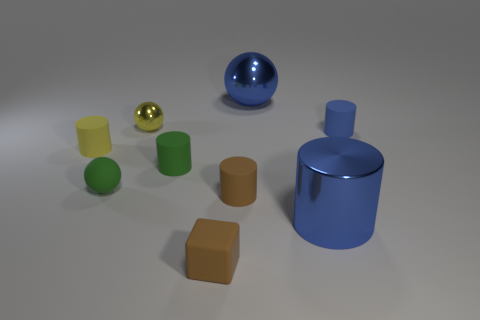There is a metal cylinder; is it the same color as the tiny rubber cylinder on the left side of the tiny green sphere?
Give a very brief answer. No. What number of objects are either tiny shiny cylinders or tiny cylinders on the left side of the rubber ball?
Provide a short and direct response. 1. There is a cylinder behind the yellow cylinder that is behind the small green rubber sphere; what size is it?
Your answer should be compact. Small. Are there an equal number of big balls on the right side of the tiny blue cylinder and large balls in front of the small yellow matte cylinder?
Your answer should be very brief. Yes. Is there a yellow object on the left side of the big blue metal object that is to the left of the big blue cylinder?
Offer a terse response. Yes. What shape is the yellow thing that is the same material as the big blue ball?
Your answer should be compact. Sphere. Are there any other things of the same color as the tiny cube?
Make the answer very short. Yes. What material is the big thing that is in front of the blue thing that is behind the small blue cylinder made of?
Ensure brevity in your answer.  Metal. Is there a big blue thing that has the same shape as the tiny yellow metal thing?
Provide a short and direct response. Yes. What number of other objects are there of the same shape as the yellow rubber object?
Ensure brevity in your answer.  4. 